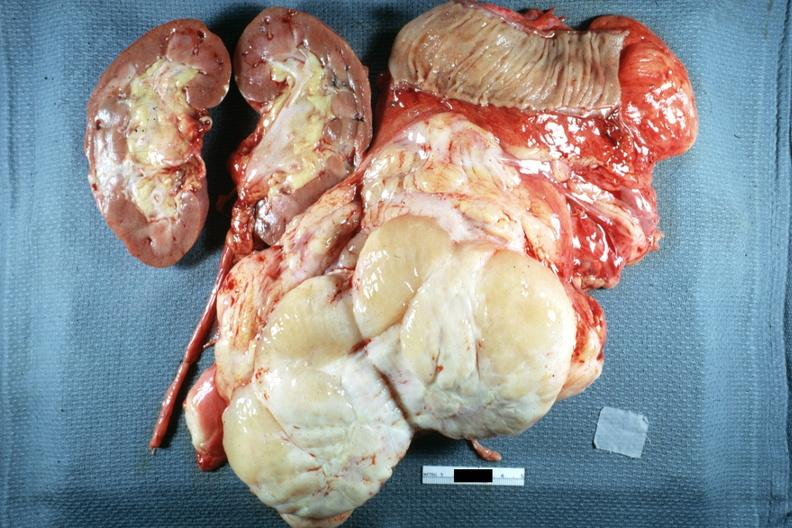what shows typical fish flesh and yellow sarcoma?
Answer the question using a single word or phrase. Whole tumor with kidney portion of jejunum resected surgically cut surface 